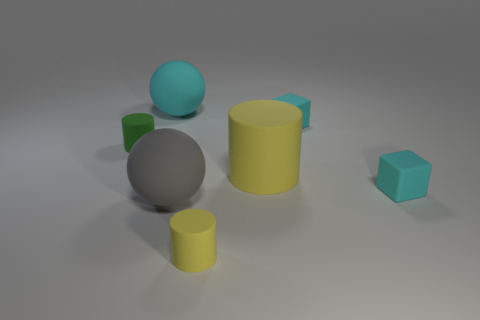How many other things are the same size as the green rubber thing?
Offer a terse response. 3. There is a yellow matte object that is behind the tiny yellow rubber cylinder in front of the big yellow thing; what size is it?
Keep it short and to the point. Large. How many big objects are either green objects or cyan balls?
Provide a short and direct response. 1. What size is the yellow rubber thing that is right of the small yellow rubber cylinder that is right of the big matte sphere behind the gray object?
Your answer should be very brief. Large. Is there anything else of the same color as the big cylinder?
Provide a succinct answer. Yes. The cylinder to the left of the big ball on the left side of the big rubber sphere in front of the large cylinder is made of what material?
Your response must be concise. Rubber. Is the small green matte object the same shape as the gray rubber thing?
Ensure brevity in your answer.  No. Is there anything else that is the same material as the large gray sphere?
Offer a very short reply. Yes. What number of big rubber objects are both to the left of the small yellow object and behind the gray thing?
Ensure brevity in your answer.  1. What color is the small cylinder in front of the rubber sphere to the right of the cyan ball?
Give a very brief answer. Yellow. 